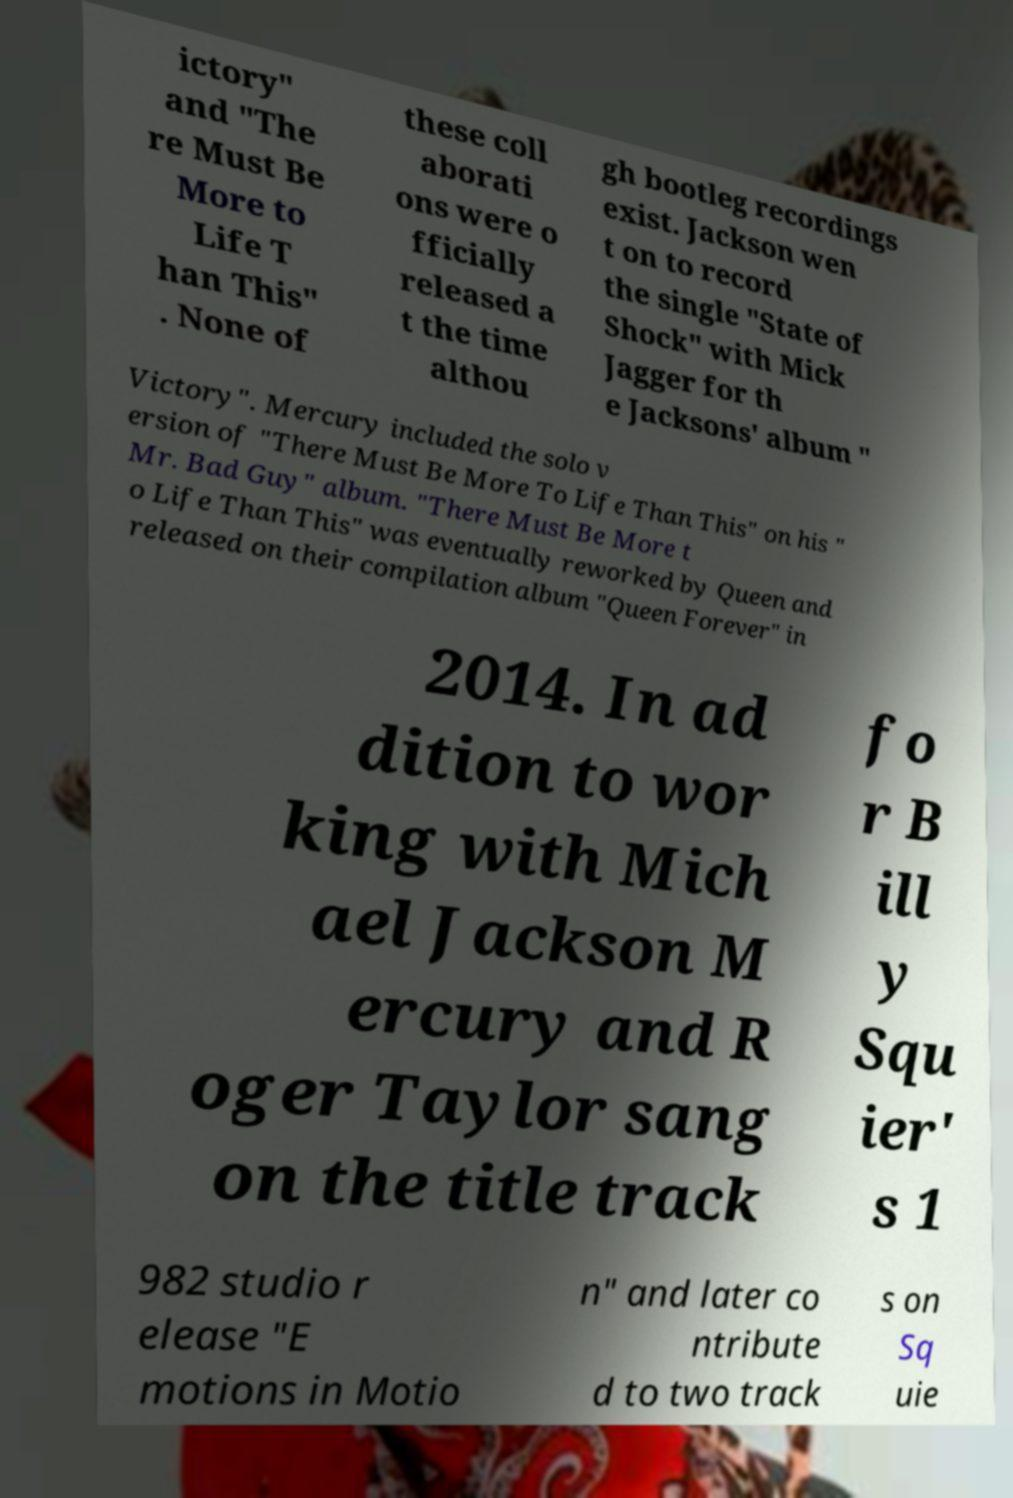There's text embedded in this image that I need extracted. Can you transcribe it verbatim? ictory" and "The re Must Be More to Life T han This" . None of these coll aborati ons were o fficially released a t the time althou gh bootleg recordings exist. Jackson wen t on to record the single "State of Shock" with Mick Jagger for th e Jacksons' album " Victory". Mercury included the solo v ersion of "There Must Be More To Life Than This" on his " Mr. Bad Guy" album. "There Must Be More t o Life Than This" was eventually reworked by Queen and released on their compilation album "Queen Forever" in 2014. In ad dition to wor king with Mich ael Jackson M ercury and R oger Taylor sang on the title track fo r B ill y Squ ier' s 1 982 studio r elease "E motions in Motio n" and later co ntribute d to two track s on Sq uie 